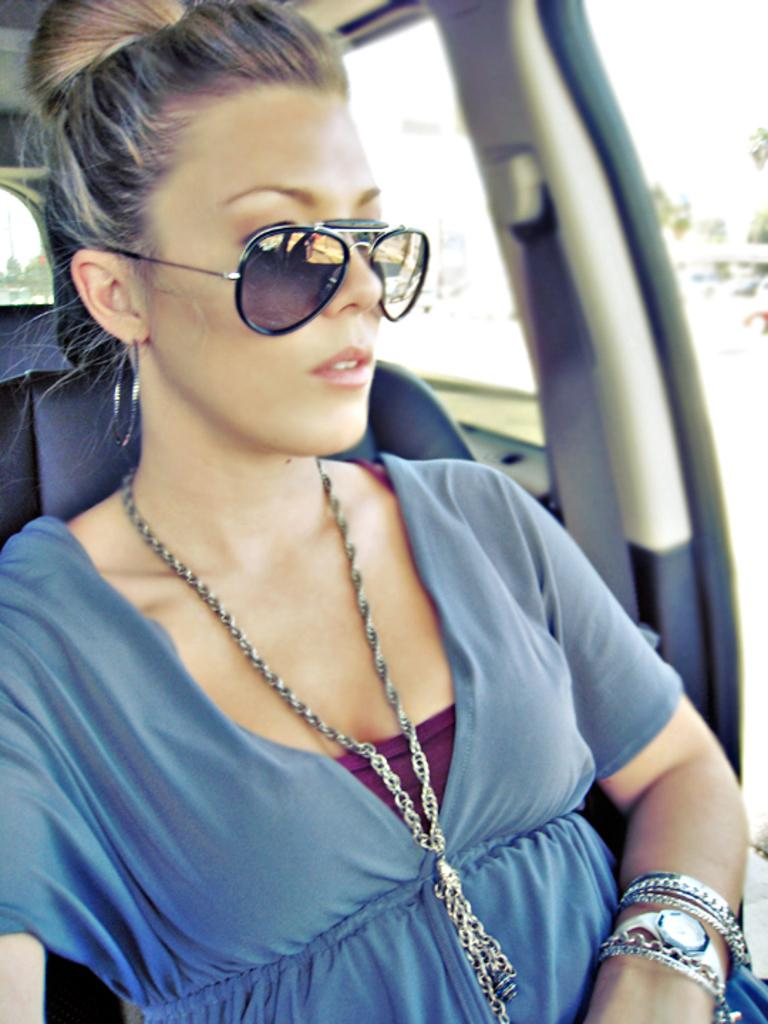Who is the main subject in the image? There is a woman in the image. What is the woman wearing? The woman is wearing a blue dress and black goggles. Where is the woman located in the image? The woman is sitting inside a vehicle. What can be seen through the windows of the vehicle? Trees and the sky are visible through the windows of the vehicle. What word is written on the quilt in the image? There is no quilt present in the image, so it is not possible to answer that question. 